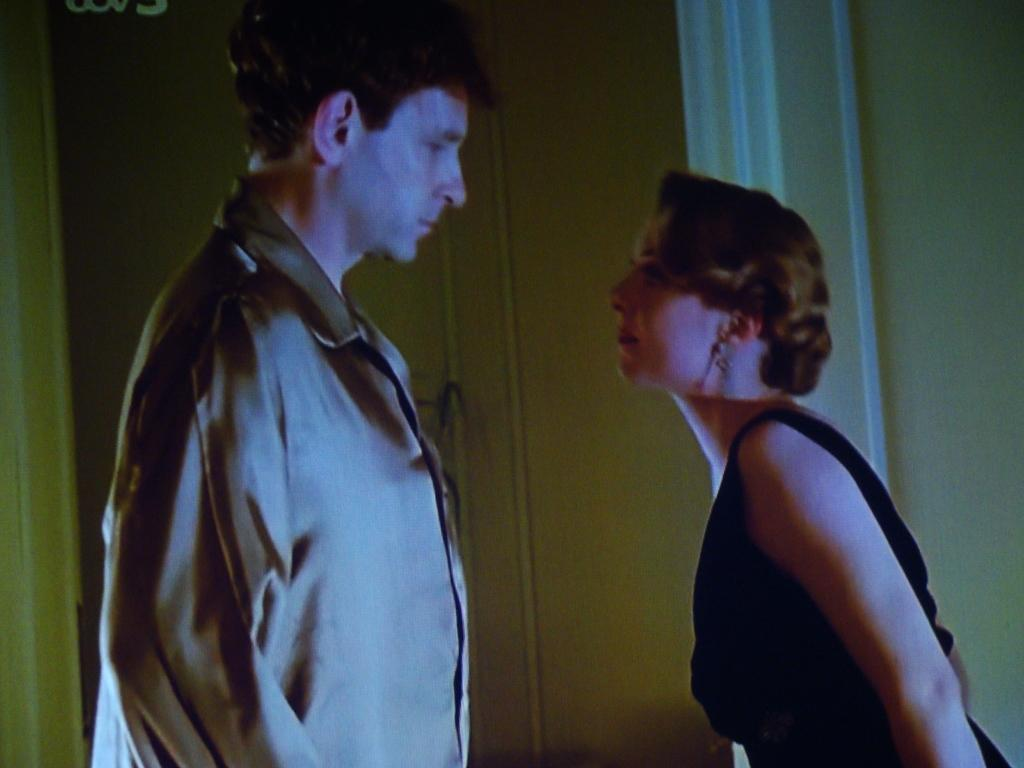How many people are in the image? There are two people in the image. Can you describe the gender of each person? One person is a man, and the other person is a woman. What are the positions of the man and woman in the image? Both the man and the woman are standing. What color is the sock on the woman's foot in the image? There is no sock visible on the woman's foot in the image. How low is the yarn hanging from the ceiling in the image? There is no yarn hanging from the ceiling in the image. 